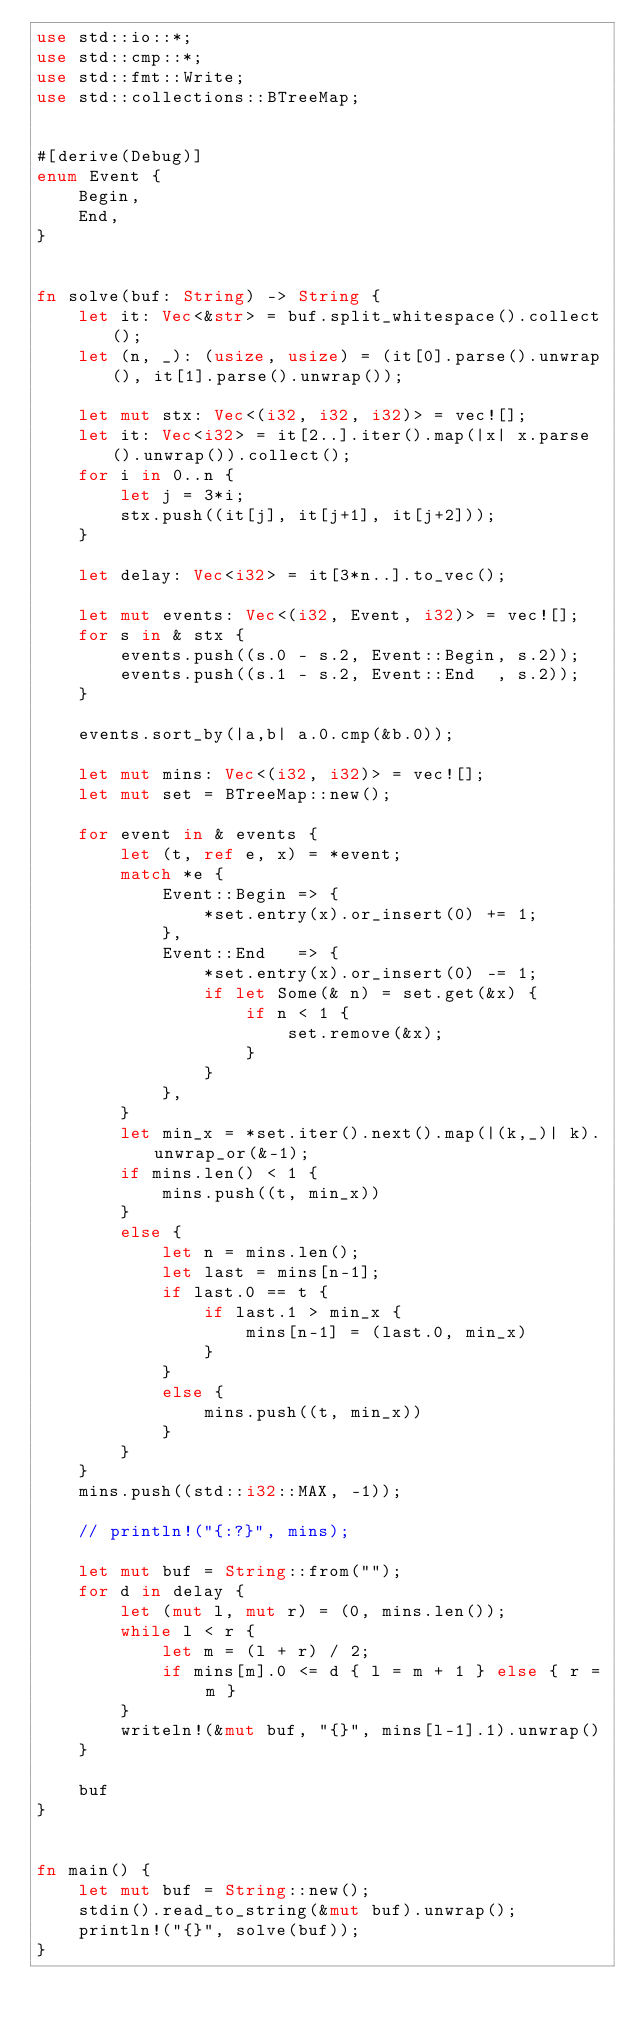<code> <loc_0><loc_0><loc_500><loc_500><_Rust_>use std::io::*;
use std::cmp::*;
use std::fmt::Write;
use std::collections::BTreeMap;


#[derive(Debug)]
enum Event {
    Begin,
    End,
}


fn solve(buf: String) -> String {
    let it: Vec<&str> = buf.split_whitespace().collect();
    let (n, _): (usize, usize) = (it[0].parse().unwrap(), it[1].parse().unwrap());

    let mut stx: Vec<(i32, i32, i32)> = vec![];
    let it: Vec<i32> = it[2..].iter().map(|x| x.parse().unwrap()).collect();
    for i in 0..n {
        let j = 3*i;
        stx.push((it[j], it[j+1], it[j+2]));
    }

    let delay: Vec<i32> = it[3*n..].to_vec();

    let mut events: Vec<(i32, Event, i32)> = vec![];
    for s in & stx {
        events.push((s.0 - s.2, Event::Begin, s.2));
        events.push((s.1 - s.2, Event::End  , s.2));
    }

    events.sort_by(|a,b| a.0.cmp(&b.0));

    let mut mins: Vec<(i32, i32)> = vec![];
    let mut set = BTreeMap::new();

    for event in & events {
        let (t, ref e, x) = *event;
        match *e {
            Event::Begin => {
                *set.entry(x).or_insert(0) += 1;
            },
            Event::End   => {
                *set.entry(x).or_insert(0) -= 1;
                if let Some(& n) = set.get(&x) {
                    if n < 1 {
                        set.remove(&x);
                    }
                }
            },
        }
        let min_x = *set.iter().next().map(|(k,_)| k).unwrap_or(&-1);
        if mins.len() < 1 {
            mins.push((t, min_x))
        }
        else {
            let n = mins.len();
            let last = mins[n-1];
            if last.0 == t {
                if last.1 > min_x {
                    mins[n-1] = (last.0, min_x)
                }
            }
            else {
                mins.push((t, min_x))
            }
        }
    }
    mins.push((std::i32::MAX, -1));

    // println!("{:?}", mins);

    let mut buf = String::from("");
    for d in delay {
        let (mut l, mut r) = (0, mins.len());
        while l < r {
            let m = (l + r) / 2;
            if mins[m].0 <= d { l = m + 1 } else { r = m }
        }
        writeln!(&mut buf, "{}", mins[l-1].1).unwrap()
    }

    buf
}


fn main() {
    let mut buf = String::new();
    stdin().read_to_string(&mut buf).unwrap();
    println!("{}", solve(buf));
}</code> 